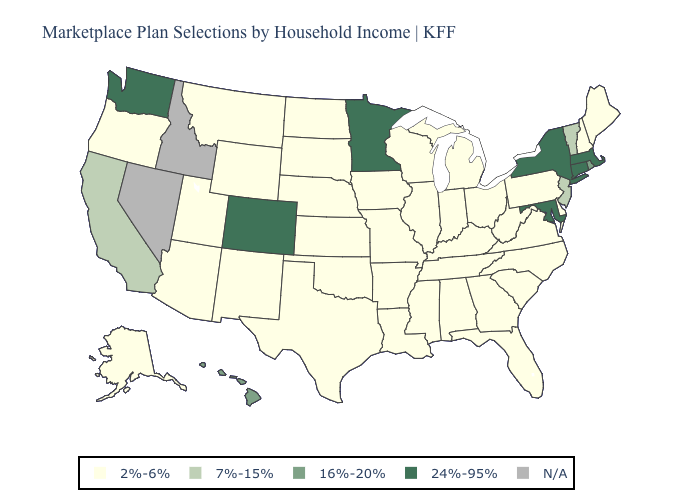What is the lowest value in the USA?
Quick response, please. 2%-6%. Name the states that have a value in the range 7%-15%?
Be succinct. California, New Jersey, Vermont. Which states hav the highest value in the South?
Write a very short answer. Maryland. What is the lowest value in the USA?
Be succinct. 2%-6%. Does the map have missing data?
Concise answer only. Yes. Among the states that border Vermont , which have the lowest value?
Short answer required. New Hampshire. Does Maryland have the highest value in the USA?
Give a very brief answer. Yes. Among the states that border Arkansas , which have the lowest value?
Be succinct. Louisiana, Mississippi, Missouri, Oklahoma, Tennessee, Texas. Which states have the highest value in the USA?
Short answer required. Colorado, Connecticut, Maryland, Massachusetts, Minnesota, New York, Washington. Name the states that have a value in the range 7%-15%?
Quick response, please. California, New Jersey, Vermont. What is the highest value in the West ?
Write a very short answer. 24%-95%. What is the value of Kentucky?
Give a very brief answer. 2%-6%. What is the highest value in the Northeast ?
Concise answer only. 24%-95%. Name the states that have a value in the range 2%-6%?
Short answer required. Alabama, Alaska, Arizona, Arkansas, Delaware, Florida, Georgia, Illinois, Indiana, Iowa, Kansas, Kentucky, Louisiana, Maine, Michigan, Mississippi, Missouri, Montana, Nebraska, New Hampshire, New Mexico, North Carolina, North Dakota, Ohio, Oklahoma, Oregon, Pennsylvania, South Carolina, South Dakota, Tennessee, Texas, Utah, Virginia, West Virginia, Wisconsin, Wyoming. 